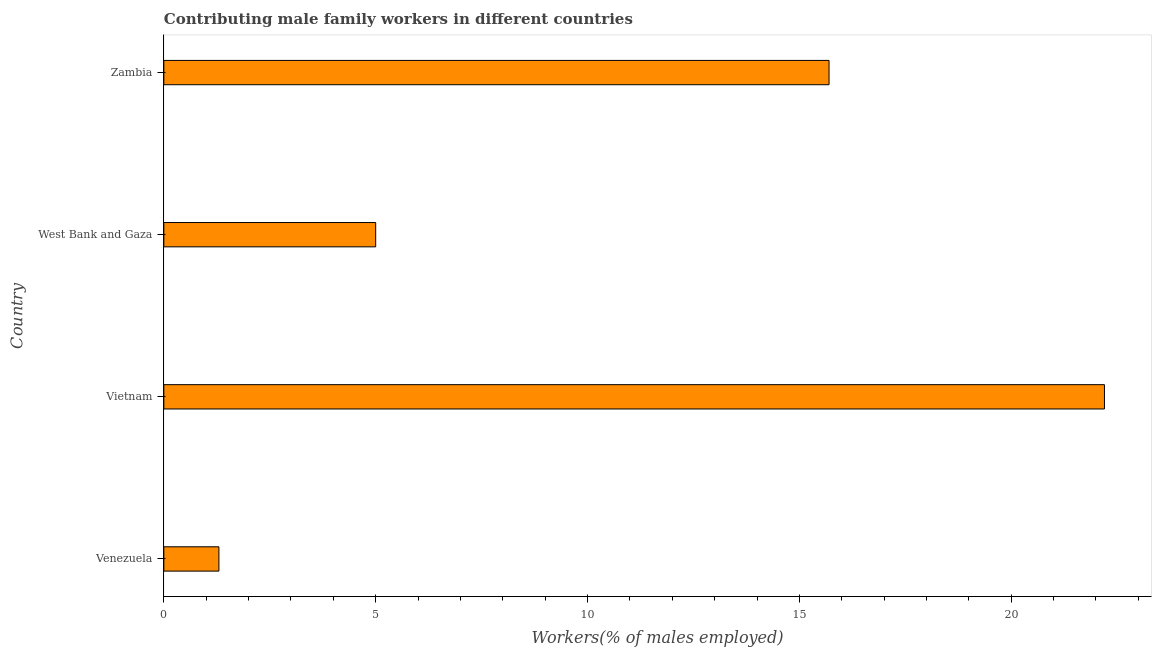Does the graph contain any zero values?
Provide a short and direct response. No. What is the title of the graph?
Provide a succinct answer. Contributing male family workers in different countries. What is the label or title of the X-axis?
Make the answer very short. Workers(% of males employed). What is the contributing male family workers in Vietnam?
Provide a short and direct response. 22.2. Across all countries, what is the maximum contributing male family workers?
Offer a very short reply. 22.2. Across all countries, what is the minimum contributing male family workers?
Keep it short and to the point. 1.3. In which country was the contributing male family workers maximum?
Your answer should be compact. Vietnam. In which country was the contributing male family workers minimum?
Your response must be concise. Venezuela. What is the sum of the contributing male family workers?
Offer a terse response. 44.2. What is the difference between the contributing male family workers in Vietnam and Zambia?
Offer a very short reply. 6.5. What is the average contributing male family workers per country?
Ensure brevity in your answer.  11.05. What is the median contributing male family workers?
Ensure brevity in your answer.  10.35. In how many countries, is the contributing male family workers greater than 11 %?
Ensure brevity in your answer.  2. What is the ratio of the contributing male family workers in Venezuela to that in Vietnam?
Keep it short and to the point. 0.06. What is the difference between the highest and the lowest contributing male family workers?
Provide a succinct answer. 20.9. What is the Workers(% of males employed) of Venezuela?
Provide a succinct answer. 1.3. What is the Workers(% of males employed) in Vietnam?
Offer a very short reply. 22.2. What is the Workers(% of males employed) in West Bank and Gaza?
Provide a succinct answer. 5. What is the Workers(% of males employed) in Zambia?
Your answer should be compact. 15.7. What is the difference between the Workers(% of males employed) in Venezuela and Vietnam?
Provide a short and direct response. -20.9. What is the difference between the Workers(% of males employed) in Venezuela and West Bank and Gaza?
Your answer should be very brief. -3.7. What is the difference between the Workers(% of males employed) in Venezuela and Zambia?
Your response must be concise. -14.4. What is the difference between the Workers(% of males employed) in Vietnam and Zambia?
Provide a short and direct response. 6.5. What is the ratio of the Workers(% of males employed) in Venezuela to that in Vietnam?
Ensure brevity in your answer.  0.06. What is the ratio of the Workers(% of males employed) in Venezuela to that in West Bank and Gaza?
Ensure brevity in your answer.  0.26. What is the ratio of the Workers(% of males employed) in Venezuela to that in Zambia?
Your answer should be very brief. 0.08. What is the ratio of the Workers(% of males employed) in Vietnam to that in West Bank and Gaza?
Provide a succinct answer. 4.44. What is the ratio of the Workers(% of males employed) in Vietnam to that in Zambia?
Give a very brief answer. 1.41. What is the ratio of the Workers(% of males employed) in West Bank and Gaza to that in Zambia?
Provide a succinct answer. 0.32. 